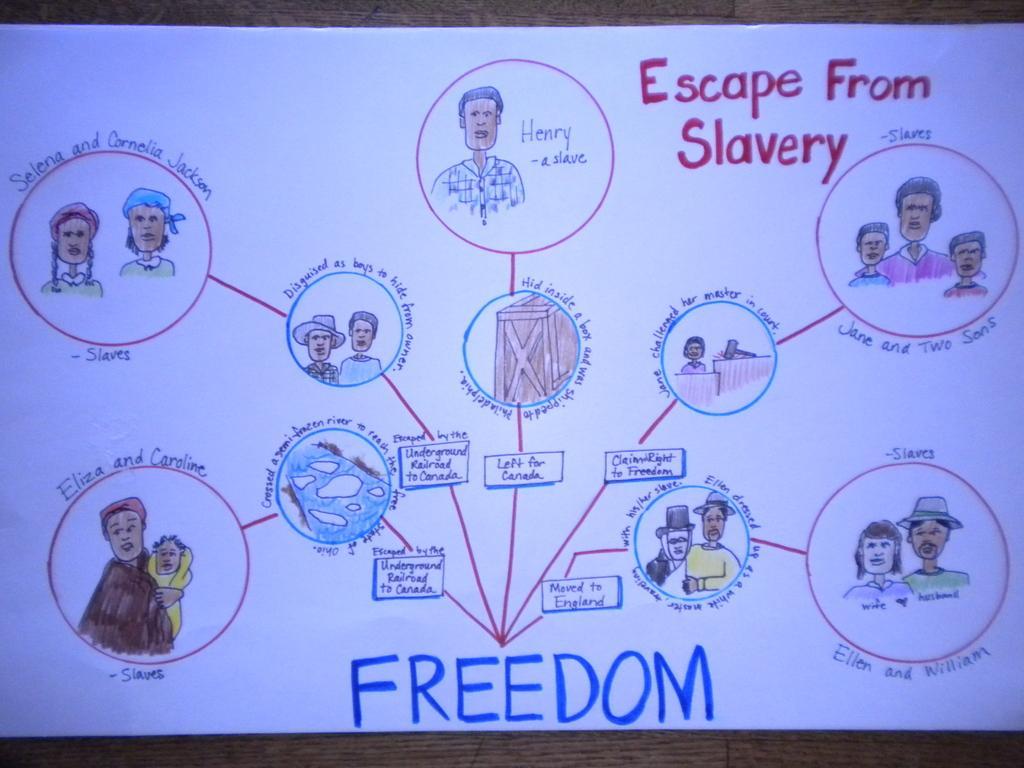How would you summarize this image in a sentence or two? In this image there is a chart. There are sketches of persons and text on the chart. 